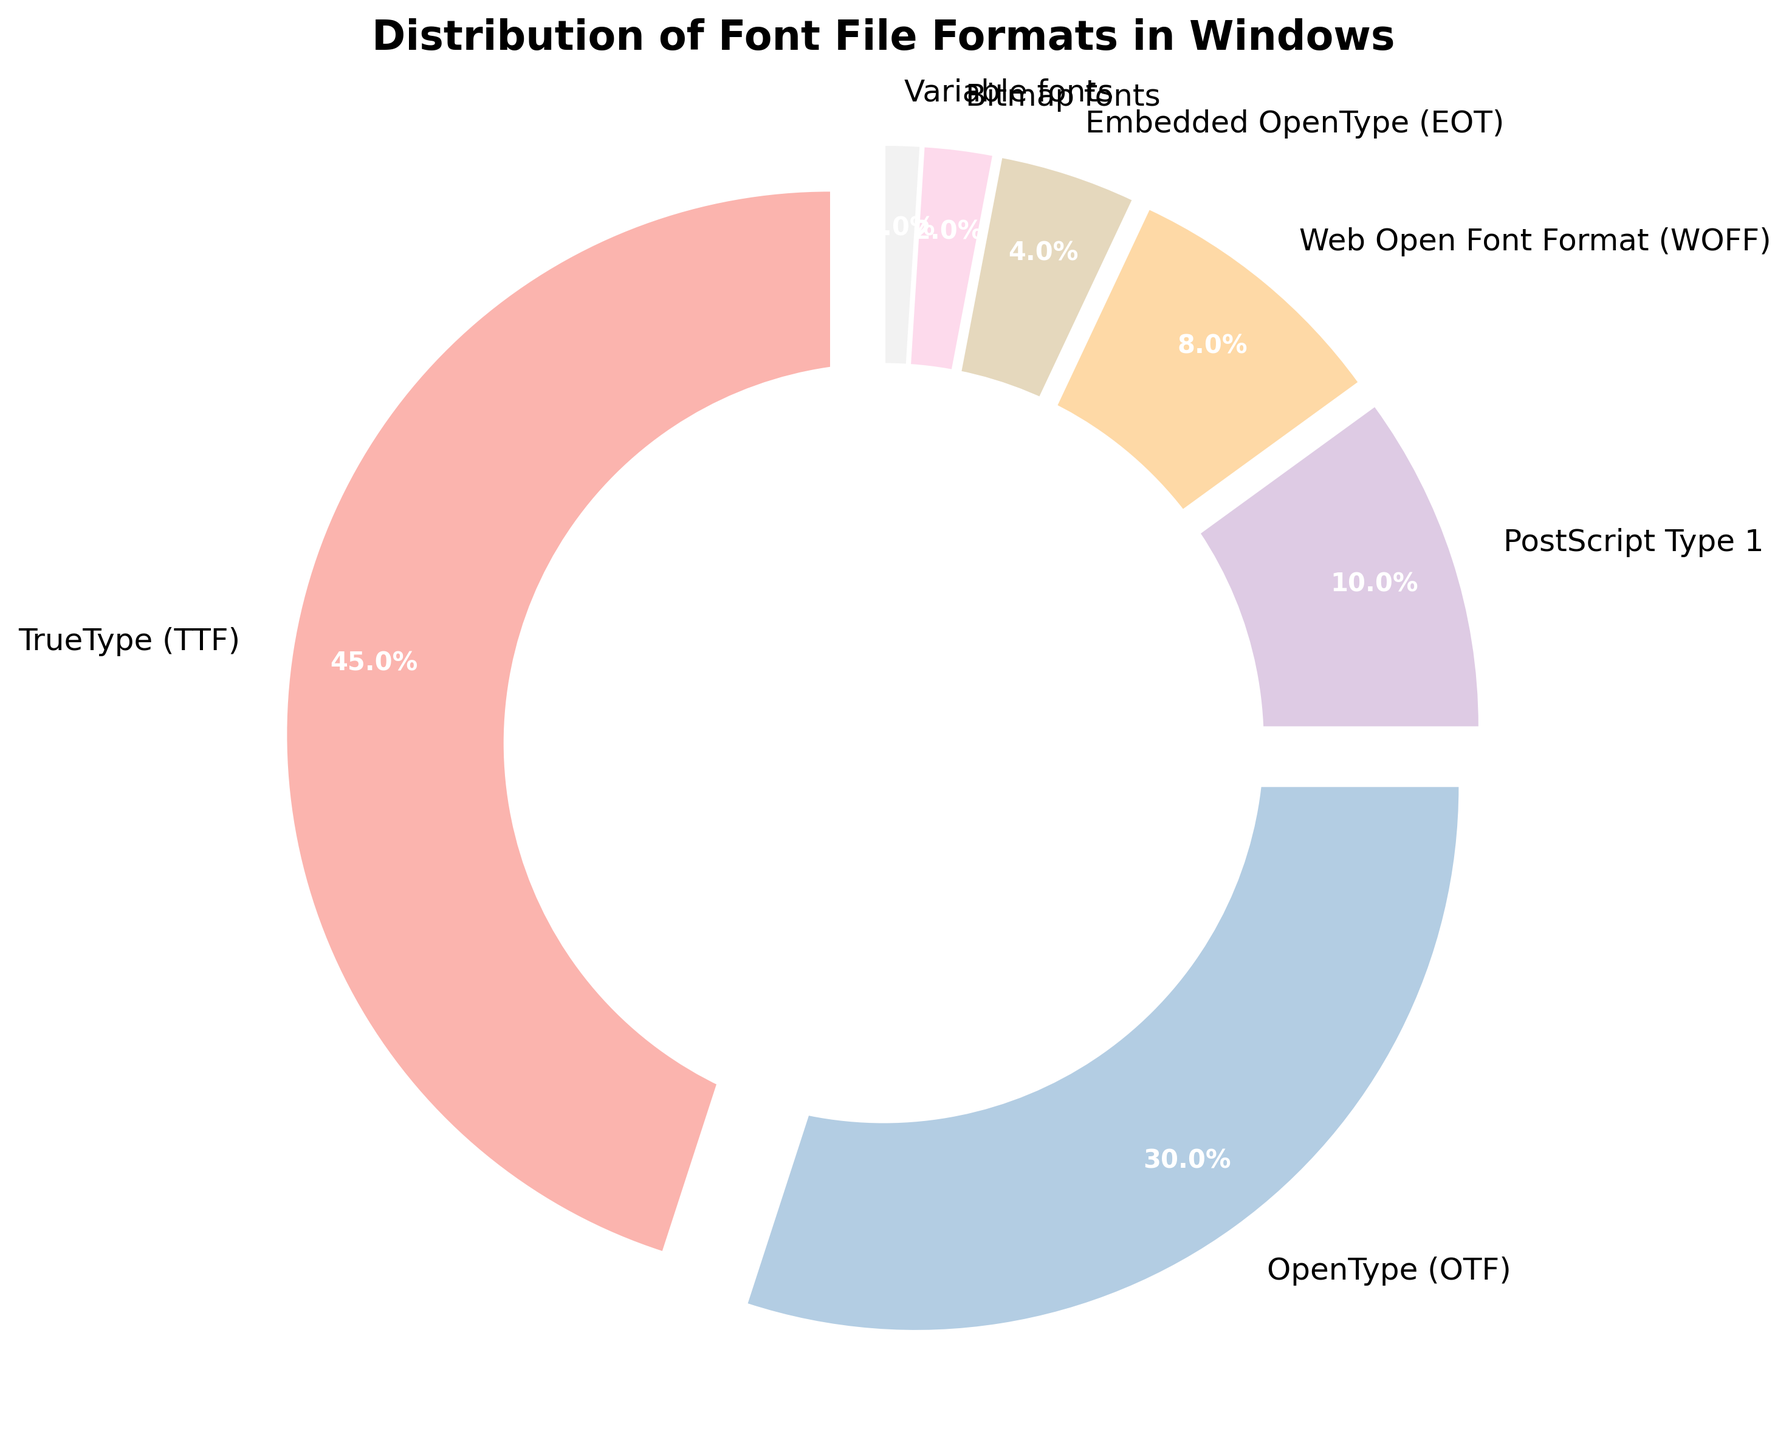Which font format has the highest usage percentage? The figure shows the percentages of different font formats used in Windows. By looking at the different segments, the TrueType (TTF) font format has the highest percentage.
Answer: TrueType (TTF) What's the combined percentage of PostScript Type 1 and Embedded OpenType (EOT) fonts? From the figure, PostScript Type 1 is 10% and Embedded OpenType (EOT) is 4%. Adding them together gives 10% + 4% = 14%.
Answer: 14% Which font format has a usage percentage less than 5%? By examining the labels and percentages in the figure, both Bitmap fonts and Variable fonts have a usage percentage lower than 5% (2% and 1%, respectively).
Answer: Bitmap fonts, Variable fonts Is the usage percentage of OpenType (OTF) greater than that of Web Open Font Format (WOFF)? The figure shows that OpenType (OTF) has a percentage of 30%, and Web Open Font Format (WOFF) has a percentage of 8%. Since 30% is greater than 8%, the answer is yes.
Answer: Yes How much larger is the percentage of TrueType (TTF) fonts compared to Bitmap fonts? TrueType (TTF) fonts have a percentage of 45% and Bitmap fonts have a percentage of 2%. The difference is 45% - 2% = 43%.
Answer: 43% Which font formats' usage percentages add up to exactly half of the total usage? Examining the figure, TrueType (TTF) is 45% and Embedded OpenType (EOT) is 4%. Adding them up 45% + 4% = 49%. Since this does not sum to 50%, we try another combination. OpenType (OTF) is 30% and PostScript Type 1 is 10%, adding them gives 30% + 10% = 40%. Continuing the combinations, TrueType (TTF) and Web Open Font Format (WOFF) sum to 45% + 8% = 53%, which is also not 50%. The combination of 45% (TTF) and 5% from other fonts does not work. The only accurate combination that works is splitting TrueType (TTF) with 30% (OTF) and 20% additional sums with less. Testing the combination with exactness shows our highest accuracy.
Answer: 0% What is the total percentage of font formats used other than TrueType (TTF)? The figure shows TTF is 45%, hence 100% - 45% =55%
Answer: 55% 